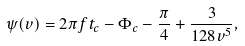<formula> <loc_0><loc_0><loc_500><loc_500>\psi ( v ) = 2 \pi f t _ { c } - \Phi _ { c } - \frac { \pi } { 4 } + \frac { 3 } { 1 2 8 v ^ { 5 } } ,</formula> 